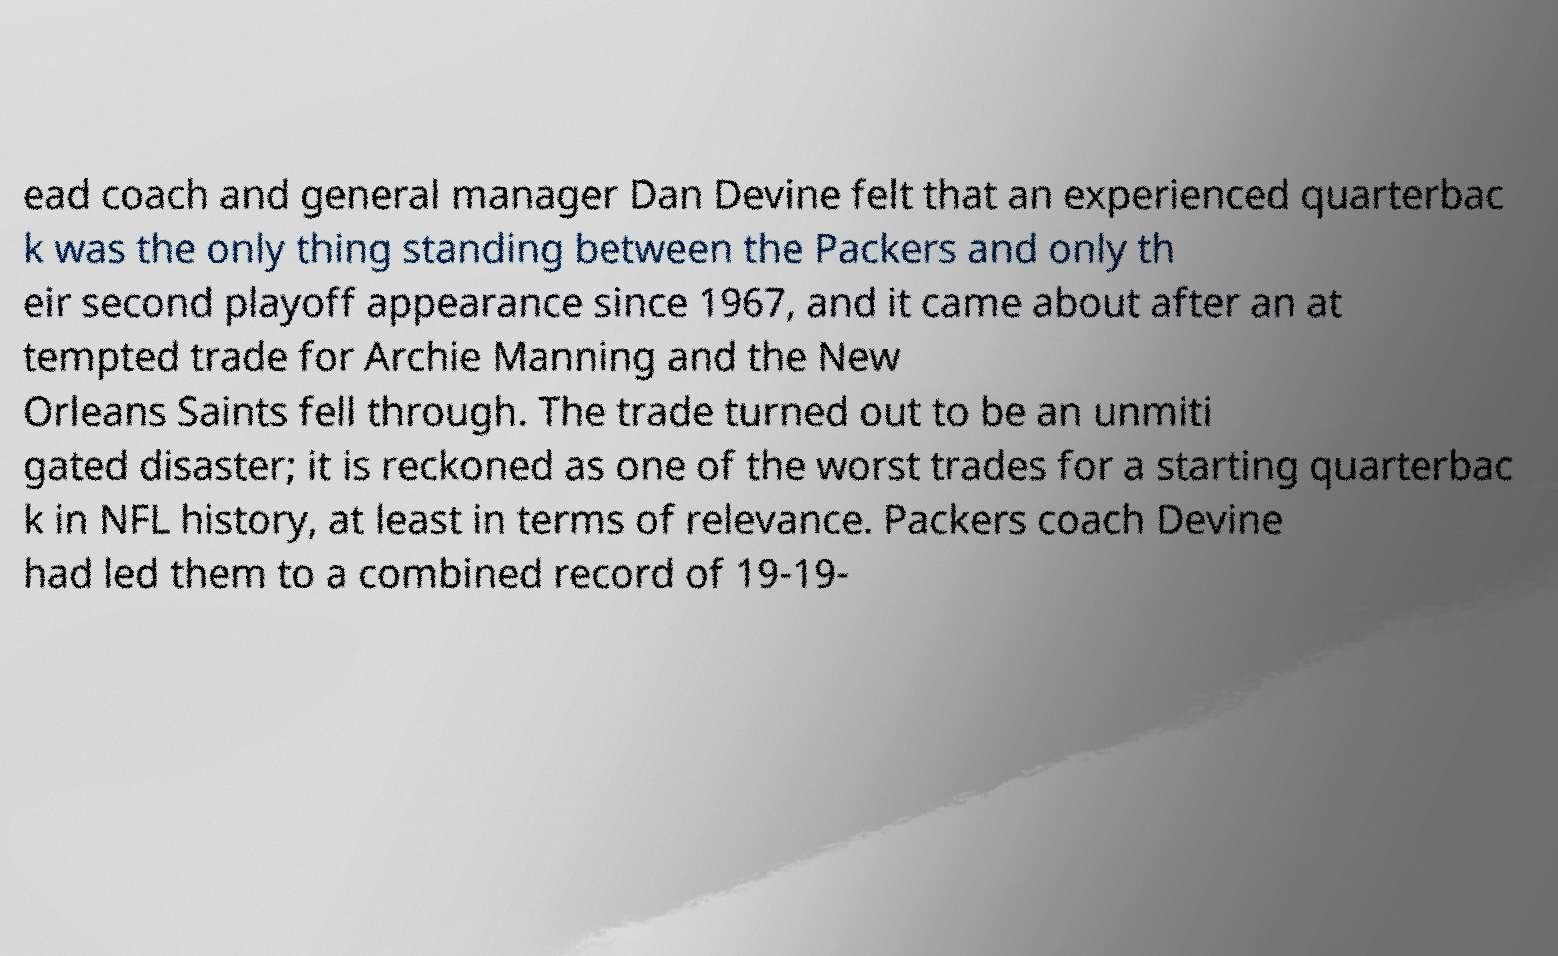Can you accurately transcribe the text from the provided image for me? ead coach and general manager Dan Devine felt that an experienced quarterbac k was the only thing standing between the Packers and only th eir second playoff appearance since 1967, and it came about after an at tempted trade for Archie Manning and the New Orleans Saints fell through. The trade turned out to be an unmiti gated disaster; it is reckoned as one of the worst trades for a starting quarterbac k in NFL history, at least in terms of relevance. Packers coach Devine had led them to a combined record of 19-19- 